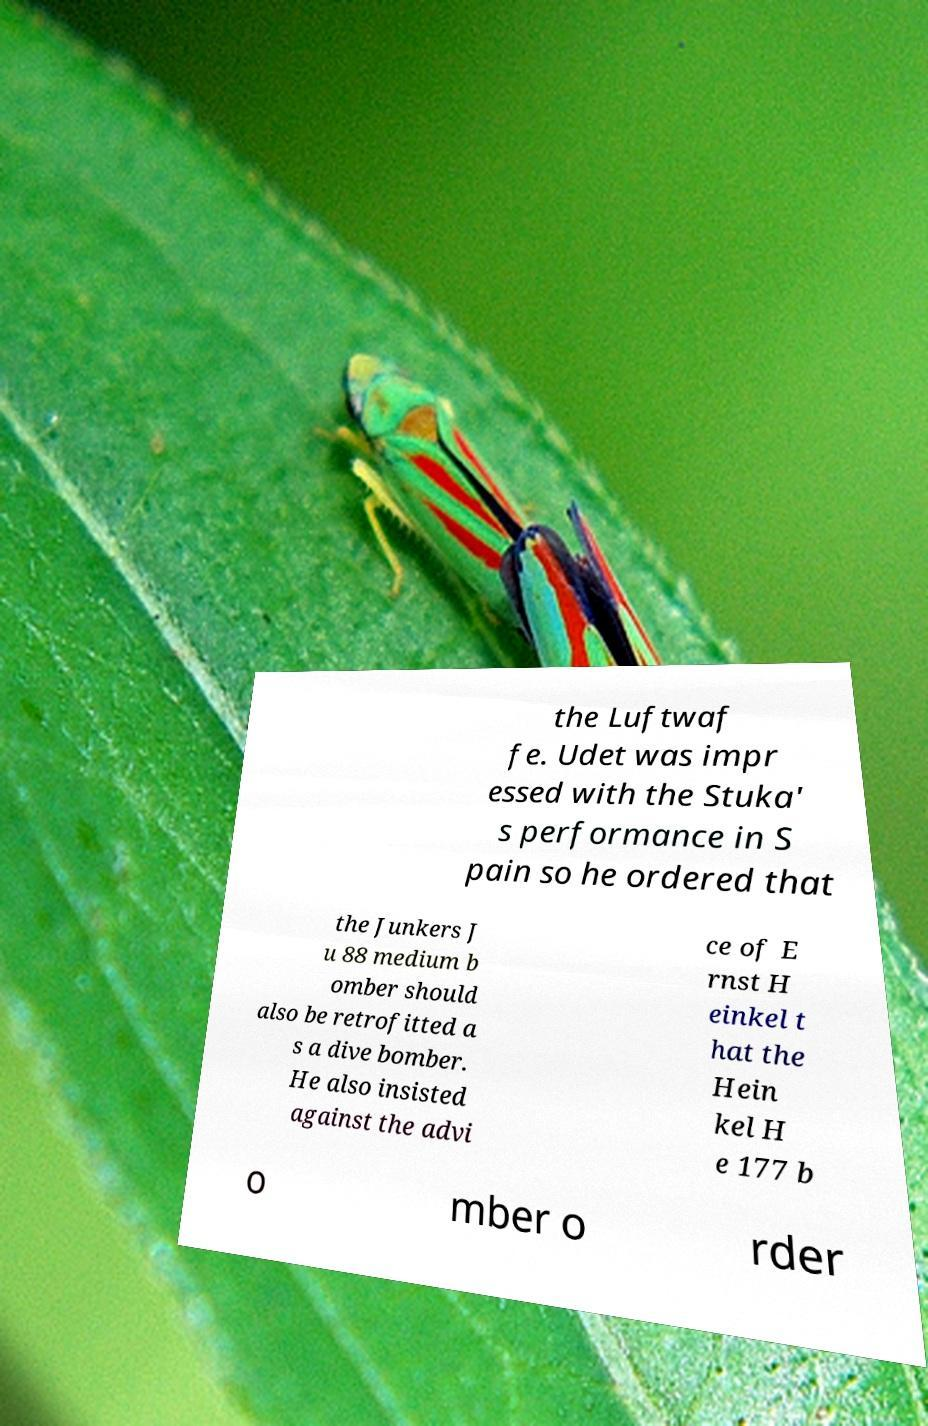There's text embedded in this image that I need extracted. Can you transcribe it verbatim? the Luftwaf fe. Udet was impr essed with the Stuka' s performance in S pain so he ordered that the Junkers J u 88 medium b omber should also be retrofitted a s a dive bomber. He also insisted against the advi ce of E rnst H einkel t hat the Hein kel H e 177 b o mber o rder 